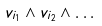Convert formula to latex. <formula><loc_0><loc_0><loc_500><loc_500>v _ { i _ { 1 } } \wedge v _ { i _ { 2 } } \wedge \dots</formula> 